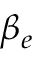Convert formula to latex. <formula><loc_0><loc_0><loc_500><loc_500>\beta _ { e }</formula> 